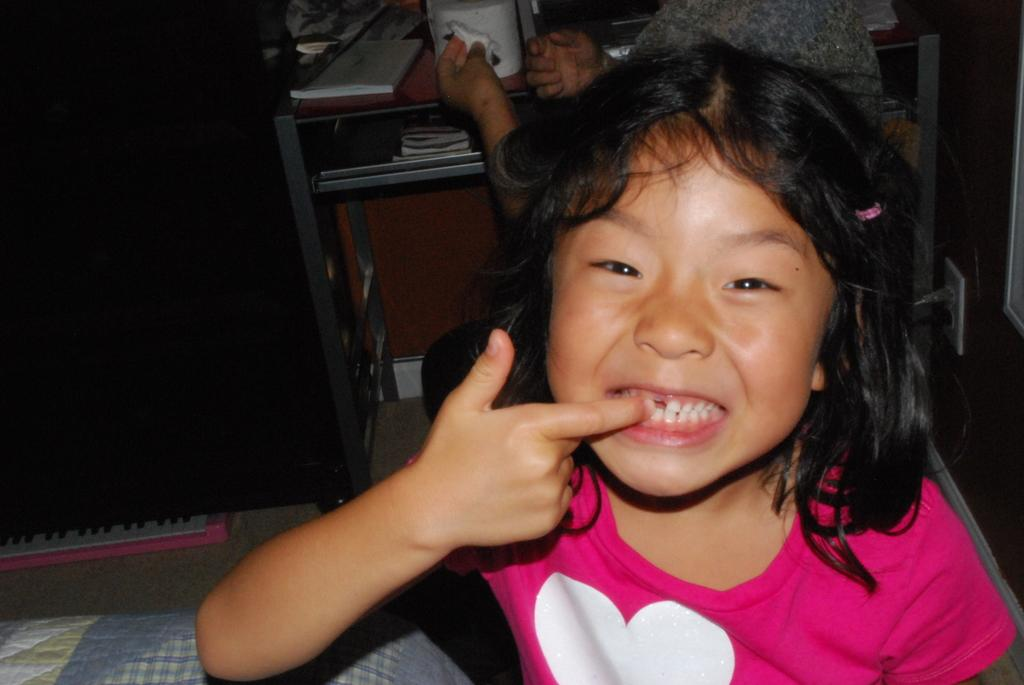What is the main subject in the foreground of the picture? There is a girl in the foreground of the picture. What else can be seen in the foreground of the picture? There is cloth and a wall in the foreground of the picture. What is located at the top of the picture? There is a desk at the top of the picture. What is on the desk? There are books on the desk. Who else is visible in the picture? There is a person at the top of the picture. What other objects can be seen at the top of the picture? There are other objects visible at the top of the picture. What type of farmer is visible at the top of the picture? There is no farmer present in the picture. How many bricks can be seen on the desk? There are no bricks visible on the desk; there are books instead. 